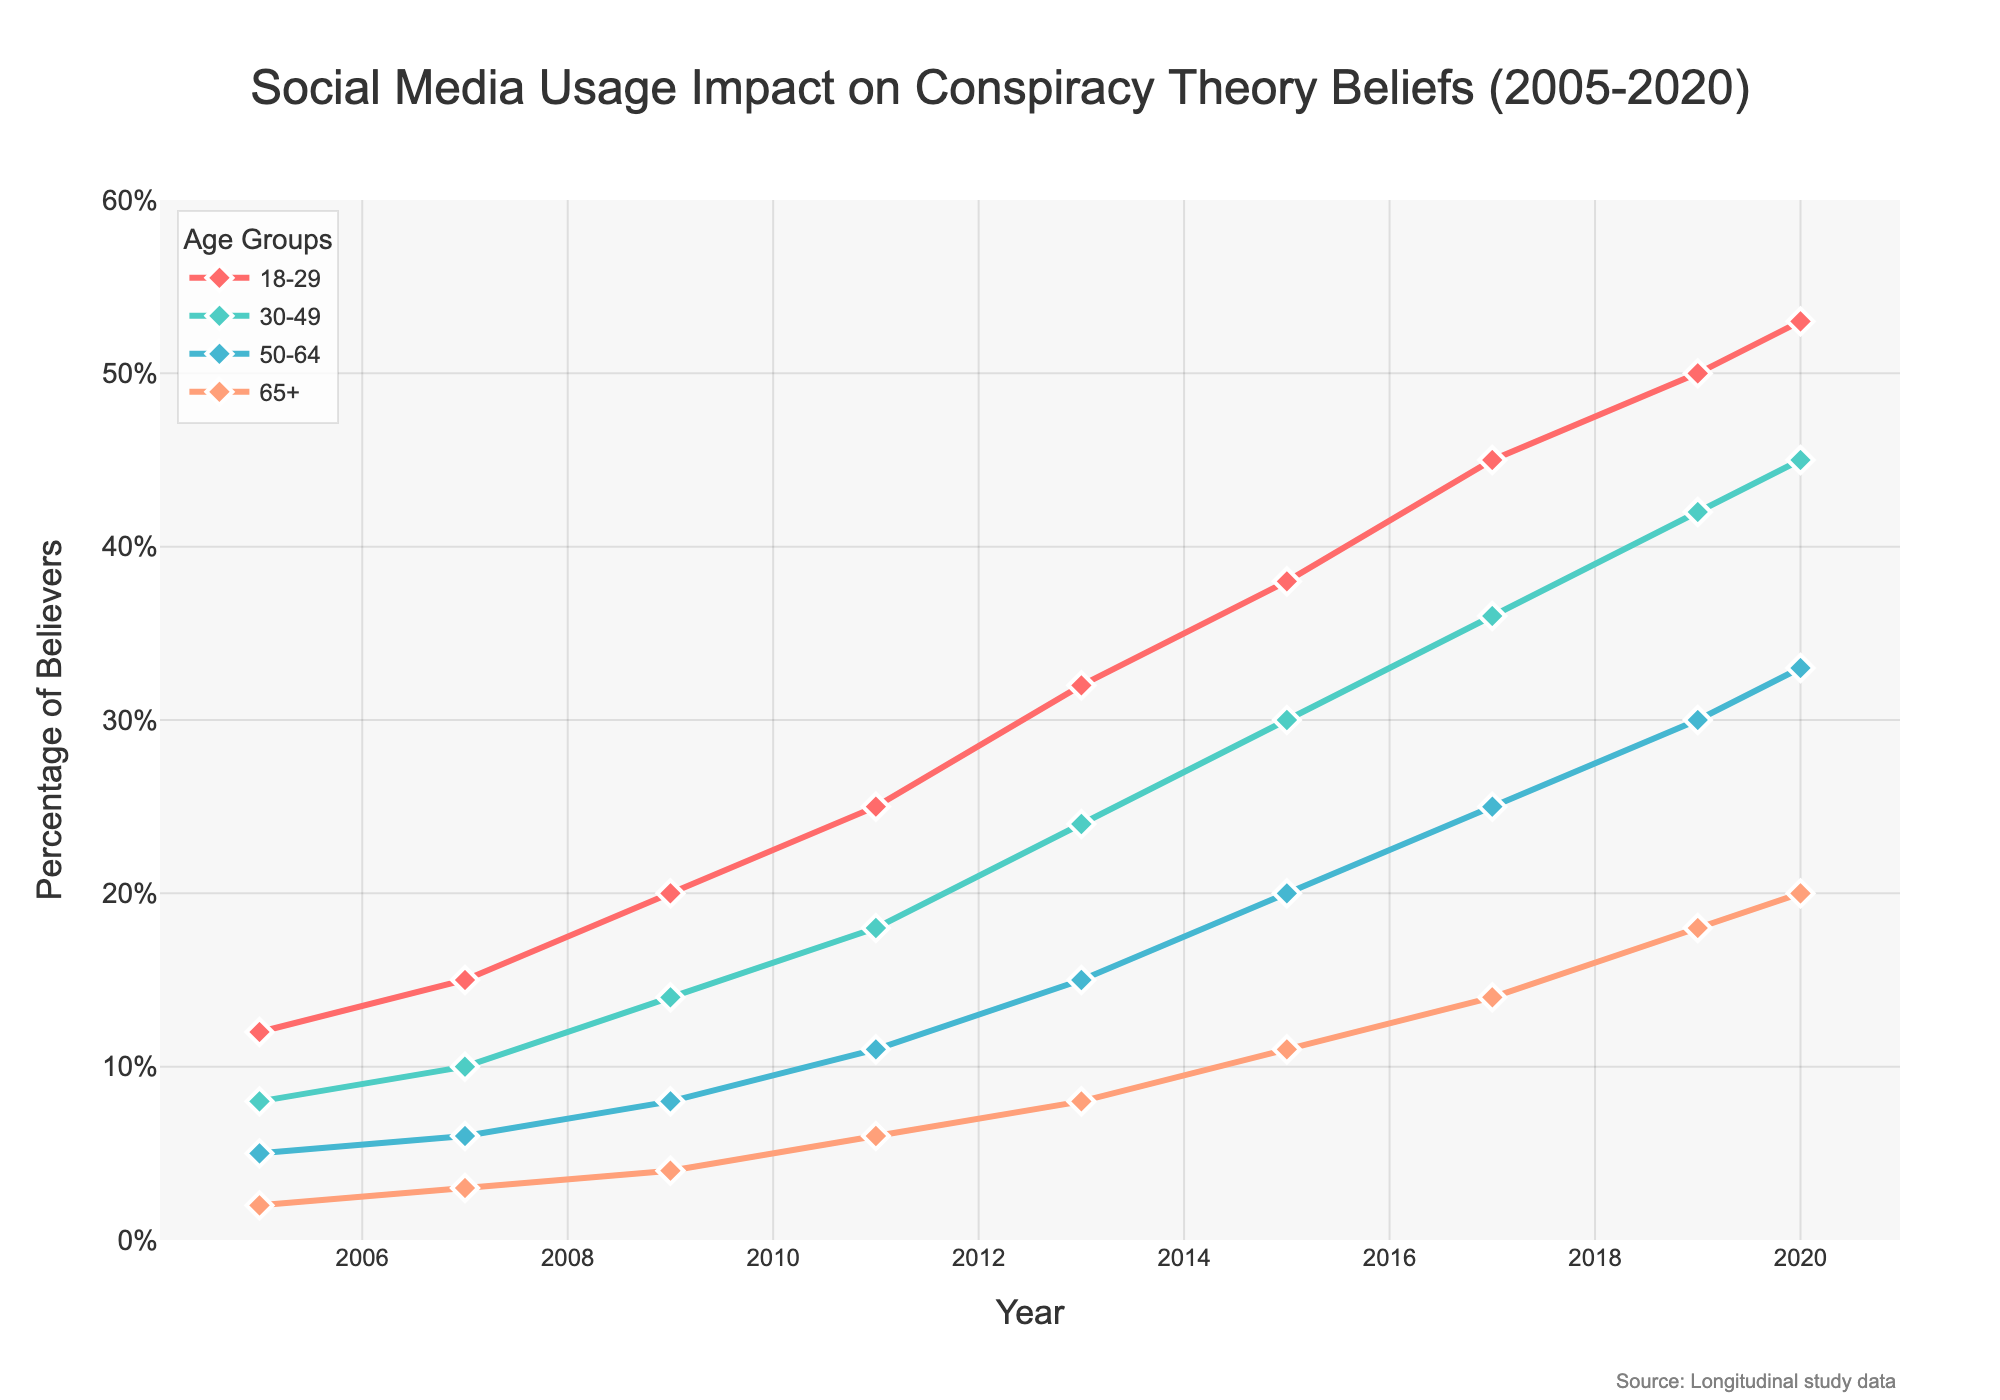What's the percentage increase in conspiracy theory beliefs among 18-29-year-olds from 2005 to 2020? To find the percentage increase: calculate the difference between values for 2005 and 2020 (53 - 12 = 41), then divide by the initial value (41 / 12), and multiply by 100 to get the percentage. (41 / 12) * 100 ≈ 341.67%
Answer: 341.67% Which age group shows the highest increase in conspiracy theory beliefs from 2005 to 2020? Compare the percentage increase for each age group from 2005 to 2020. The increases are (53-12)=41 for 18-29, (45-8)=37 for 30-49, (33-5)=28 for 50-64, and (20-2)=18 for 65+. The 18-29 age group shows the highest increase.
Answer: 18-29 How does the trend in belief percentages for the 50-64 age group compare to the 18-29 age group? Visually, both trends are increasing, but the 18-29 age group has a steeper slope, indicating a more rapid increase in beliefs. The 18-29 group consistently has higher percentages than the 50-64 group across all years.
Answer: 18-29 age group increases faster In which year did the belief percentages for the 30-49 age group exceed 20% for the first time? Inspect the line for the 30-49 age group and find the first year where the percentage is greater than 20. According to the data, it happened in 2015.
Answer: 2015 What is the difference in belief percentages between the youngest (18-29) and oldest (65+) age groups in 2020? Extract the belief percentages for both age groups in 2020 (53 for 18-29 and 20 for 65+) and subtract the older group’s percentage from the younger group’s percentage (53 - 20 = 33).
Answer: 33 Which year shows the largest single-year increase in belief percentages among the 30-49 age group? Calculate the year-over-year changes for the 30-49 group: 2007-2005 (2), 2009-2007 (4), 2011-2009 (4), 2013-2011 (6), 2015-2013 (6), 2017-2015 (6), 2019-2017 (6), 2020-2019 (3). The largest increase is from 2013 to 2015 (6%).
Answer: 2013 to 2015 What are the two age groups whose belief percentages intersect or come closest in 2020? Compare the final values of each age group in 2020: 18-29 (53%), 30-49 (45%), 50-64 (33%), 65+ (20%). The closest values are between the 30-49 and 50-64 age groups.
Answer: 30-49 and 50-64 On average, by how much did the belief percentages increase per year for the 18-29 age group from 2005 to 2020? Calculate the total increase (53 - 12 = 41) and divide by the number of intervals (2020-2005=15 years). 41 / 15 ≈ 2.73 per year.
Answer: 2.73% What is the highest percentage of believers across all age groups for any given year in the study and which year did it occur? Inspect the data table and find the maximum value: the highest percentage is 53% for the 18-29 age group in 2020.
Answer: 53%, 2020 